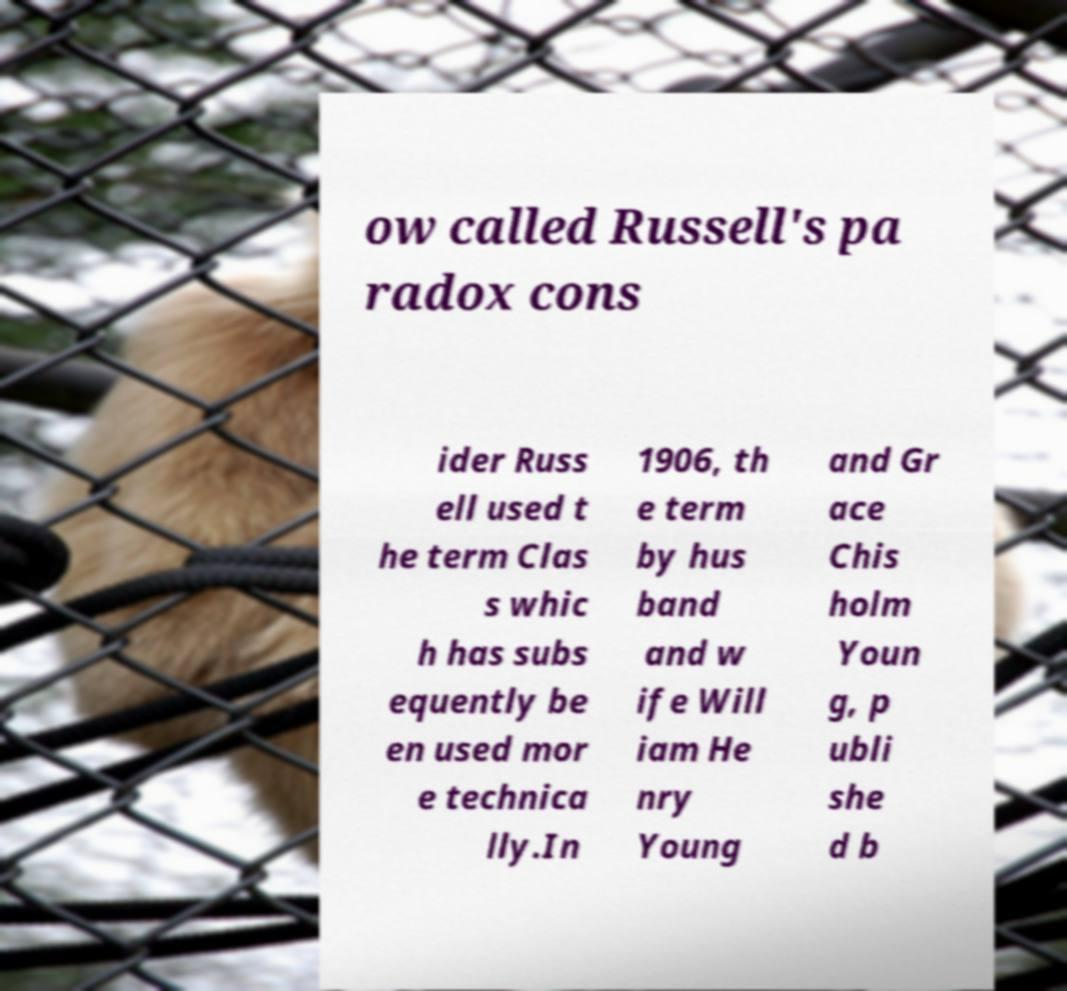There's text embedded in this image that I need extracted. Can you transcribe it verbatim? ow called Russell's pa radox cons ider Russ ell used t he term Clas s whic h has subs equently be en used mor e technica lly.In 1906, th e term by hus band and w ife Will iam He nry Young and Gr ace Chis holm Youn g, p ubli she d b 